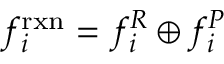<formula> <loc_0><loc_0><loc_500><loc_500>f _ { i } ^ { r x n } = f _ { i } ^ { R } \oplus f _ { i } ^ { P }</formula> 